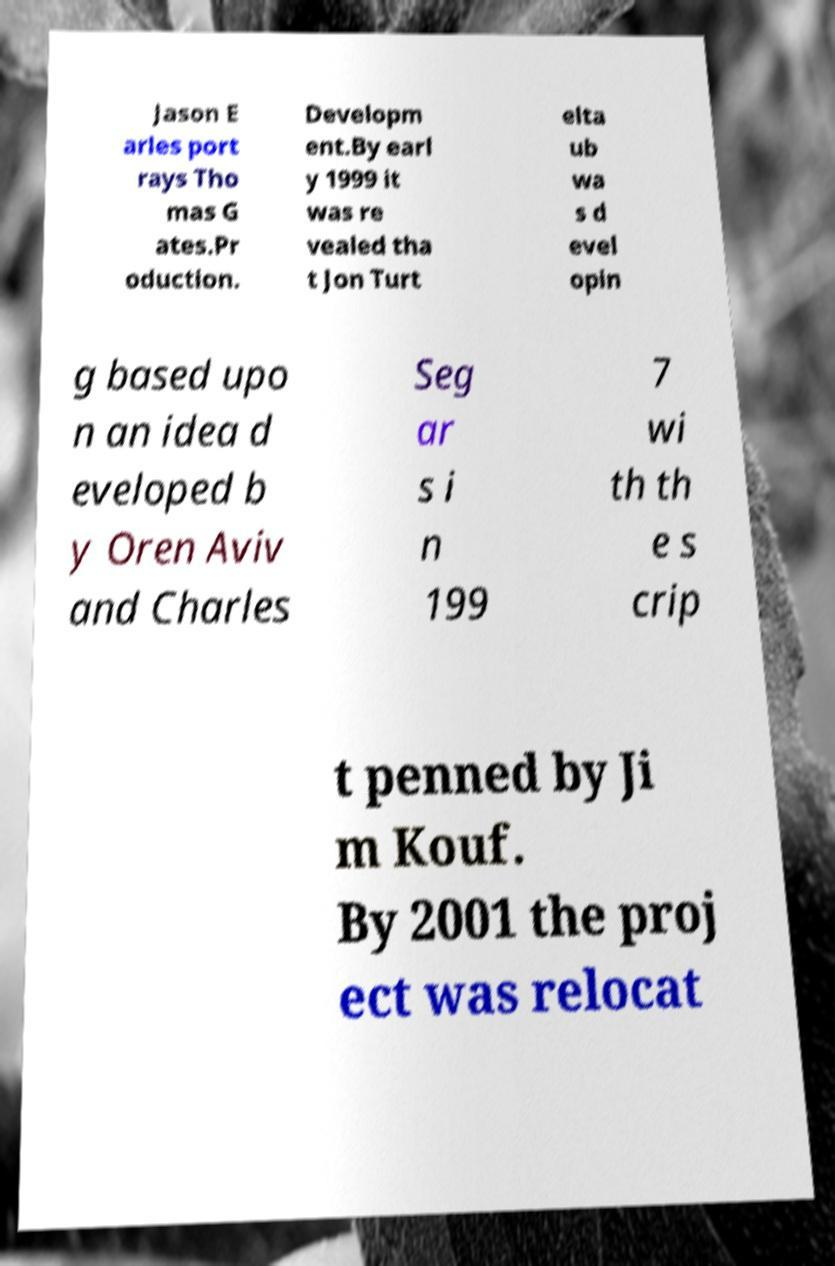Can you read and provide the text displayed in the image?This photo seems to have some interesting text. Can you extract and type it out for me? Jason E arles port rays Tho mas G ates.Pr oduction. Developm ent.By earl y 1999 it was re vealed tha t Jon Turt elta ub wa s d evel opin g based upo n an idea d eveloped b y Oren Aviv and Charles Seg ar s i n 199 7 wi th th e s crip t penned by Ji m Kouf. By 2001 the proj ect was relocat 